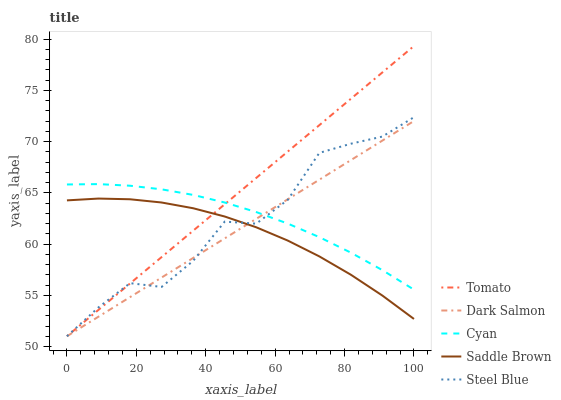Does Saddle Brown have the minimum area under the curve?
Answer yes or no. Yes. Does Tomato have the maximum area under the curve?
Answer yes or no. Yes. Does Cyan have the minimum area under the curve?
Answer yes or no. No. Does Cyan have the maximum area under the curve?
Answer yes or no. No. Is Tomato the smoothest?
Answer yes or no. Yes. Is Steel Blue the roughest?
Answer yes or no. Yes. Is Cyan the smoothest?
Answer yes or no. No. Is Cyan the roughest?
Answer yes or no. No. Does Tomato have the lowest value?
Answer yes or no. Yes. Does Cyan have the lowest value?
Answer yes or no. No. Does Tomato have the highest value?
Answer yes or no. Yes. Does Cyan have the highest value?
Answer yes or no. No. Is Saddle Brown less than Cyan?
Answer yes or no. Yes. Is Cyan greater than Saddle Brown?
Answer yes or no. Yes. Does Saddle Brown intersect Tomato?
Answer yes or no. Yes. Is Saddle Brown less than Tomato?
Answer yes or no. No. Is Saddle Brown greater than Tomato?
Answer yes or no. No. Does Saddle Brown intersect Cyan?
Answer yes or no. No. 